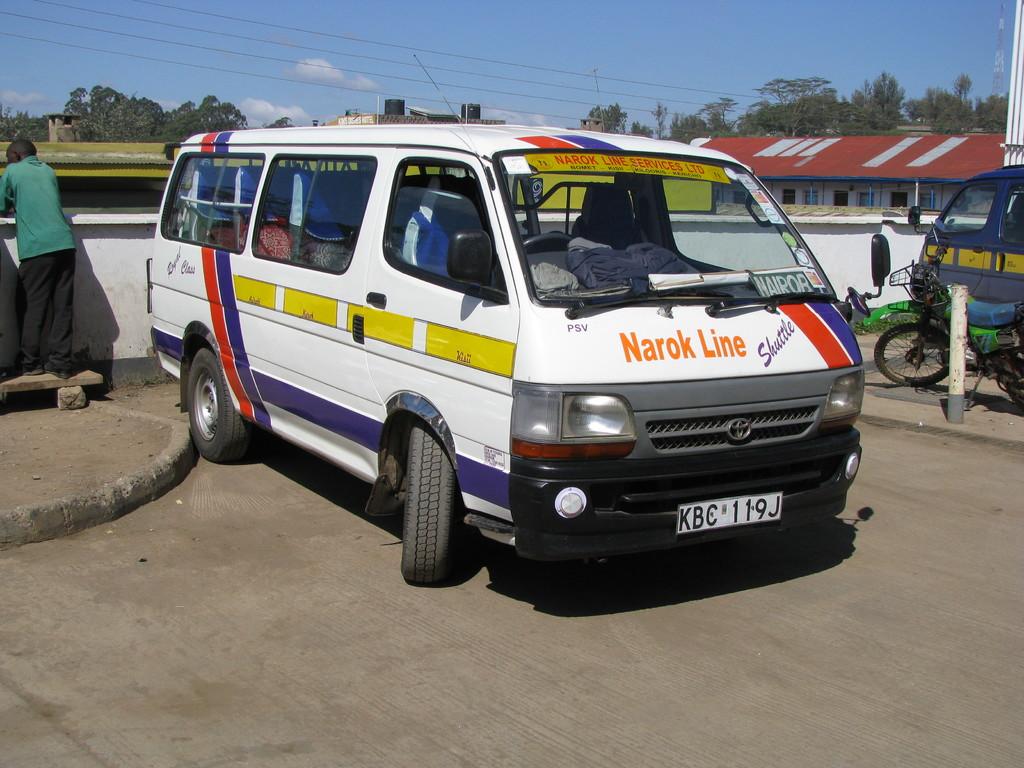What is the license plate number?
Offer a very short reply. Kbc 119j. What does the front license plate say on it?
Give a very brief answer. Kbc 119j. 